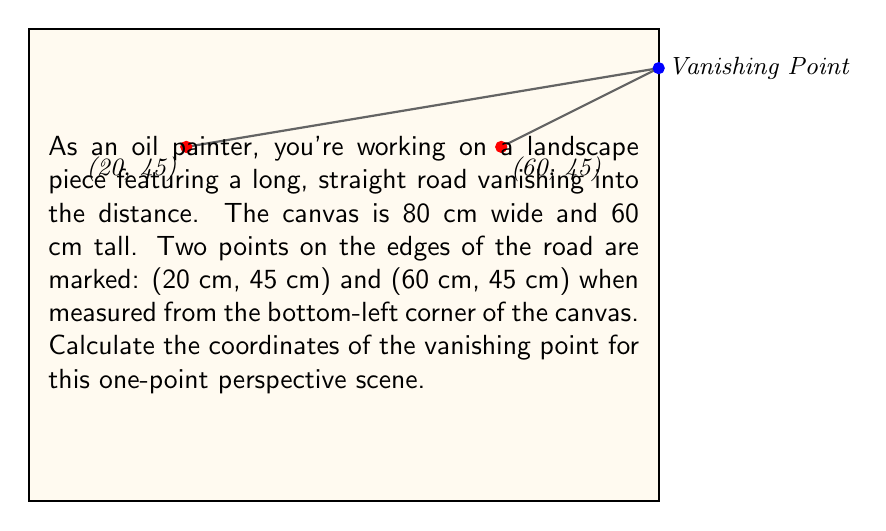Solve this math problem. To find the vanishing point coordinates, we need to extend the edges of the road until they meet. This intersection point is the vanishing point. We can use the point-slope form of a line equation to solve this problem.

Step 1: Calculate the slopes of the two lines forming the road edges.
Left edge: $m_1 = \frac{55 - 45}{80 - 20} = \frac{10}{60} = \frac{1}{6}$
Right edge: $m_2 = \frac{55 - 45}{80 - 60} = \frac{10}{20} = \frac{1}{2}$

Step 2: Write the point-slope equations for both lines.
Left edge: $y - 45 = \frac{1}{6}(x - 20)$
Right edge: $y - 45 = \frac{1}{2}(x - 60)$

Step 3: Convert to slope-intercept form (y = mx + b).
Left edge: $y = \frac{1}{6}x + 41.6667$
Right edge: $y = \frac{1}{2}x + 15$

Step 4: Set the equations equal to each other to find the x-coordinate of the intersection.
$\frac{1}{6}x + 41.6667 = \frac{1}{2}x + 15$
$\frac{1}{6}x - \frac{1}{2}x = 15 - 41.6667$
$-\frac{1}{3}x = -26.6667$
$x = 80$

Step 5: Substitute x = 80 into either equation to find the y-coordinate.
$y = \frac{1}{6}(80) + 41.6667 = 55$

Therefore, the vanishing point coordinates are (80, 55).
Answer: (80 cm, 55 cm) 